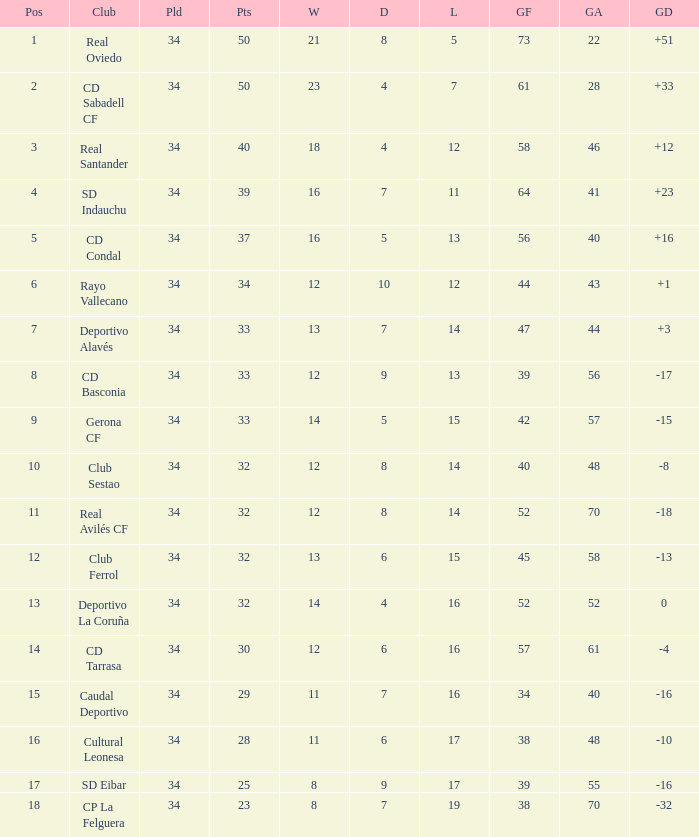Which Wins have a Goal Difference larger than 0, and Goals against larger than 40, and a Position smaller than 6, and a Club of sd indauchu? 16.0. 